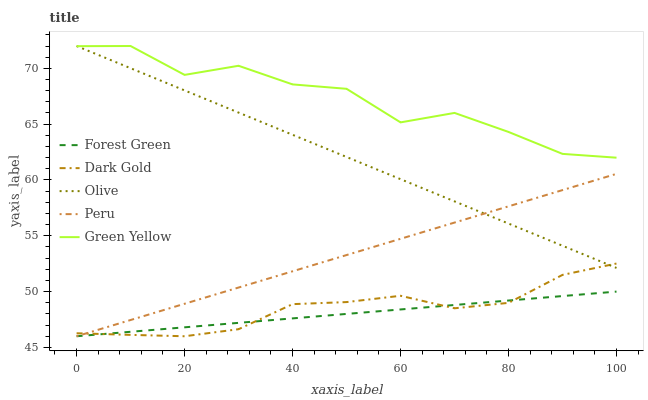Does Forest Green have the minimum area under the curve?
Answer yes or no. Yes. Does Green Yellow have the maximum area under the curve?
Answer yes or no. Yes. Does Green Yellow have the minimum area under the curve?
Answer yes or no. No. Does Forest Green have the maximum area under the curve?
Answer yes or no. No. Is Peru the smoothest?
Answer yes or no. Yes. Is Green Yellow the roughest?
Answer yes or no. Yes. Is Forest Green the smoothest?
Answer yes or no. No. Is Forest Green the roughest?
Answer yes or no. No. Does Forest Green have the lowest value?
Answer yes or no. Yes. Does Green Yellow have the lowest value?
Answer yes or no. No. Does Green Yellow have the highest value?
Answer yes or no. Yes. Does Forest Green have the highest value?
Answer yes or no. No. Is Forest Green less than Olive?
Answer yes or no. Yes. Is Olive greater than Forest Green?
Answer yes or no. Yes. Does Peru intersect Forest Green?
Answer yes or no. Yes. Is Peru less than Forest Green?
Answer yes or no. No. Is Peru greater than Forest Green?
Answer yes or no. No. Does Forest Green intersect Olive?
Answer yes or no. No. 